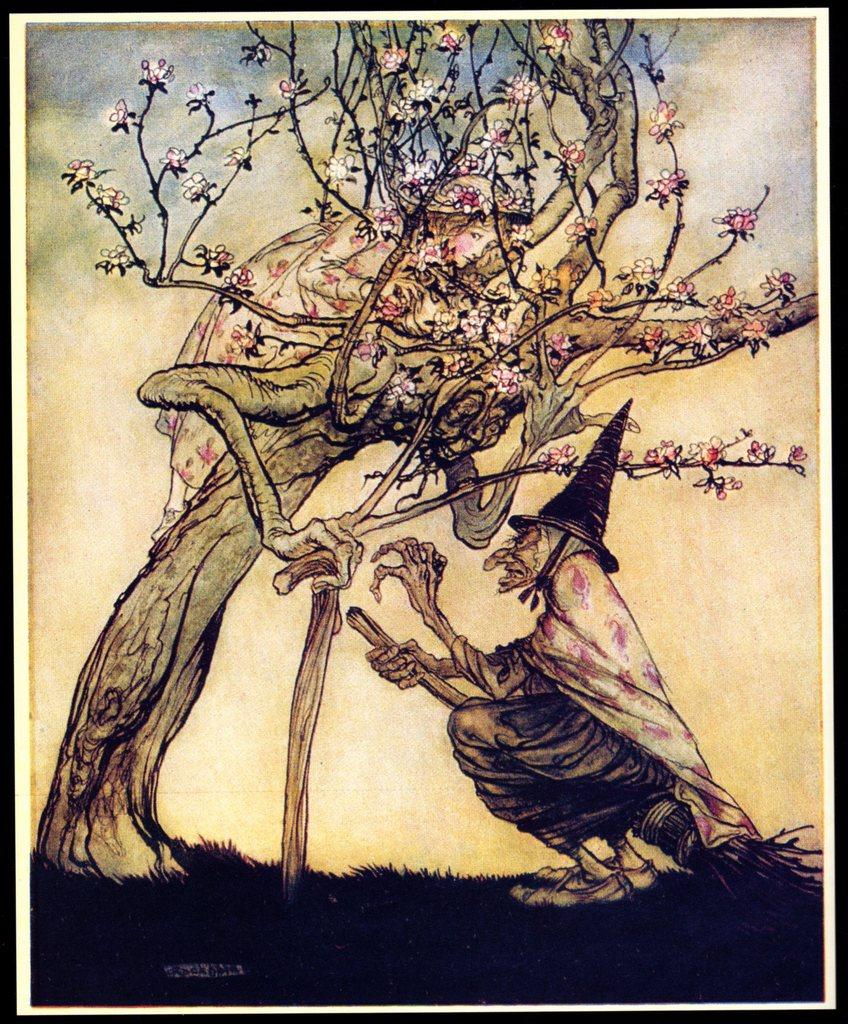What type of art is depicted in the image? There is an art of a tree and an art of a witch in the image. What can be seen in the background of the image? The background of the image includes the sky. What type of meat is hanging from the tree in the image? There is no tree with meat hanging from it in the image; it only features an art of a tree. How many clouds are present in the image? There is no mention of clouds in the image; it only features an art of a tree and an art of a witch with a sky background. 